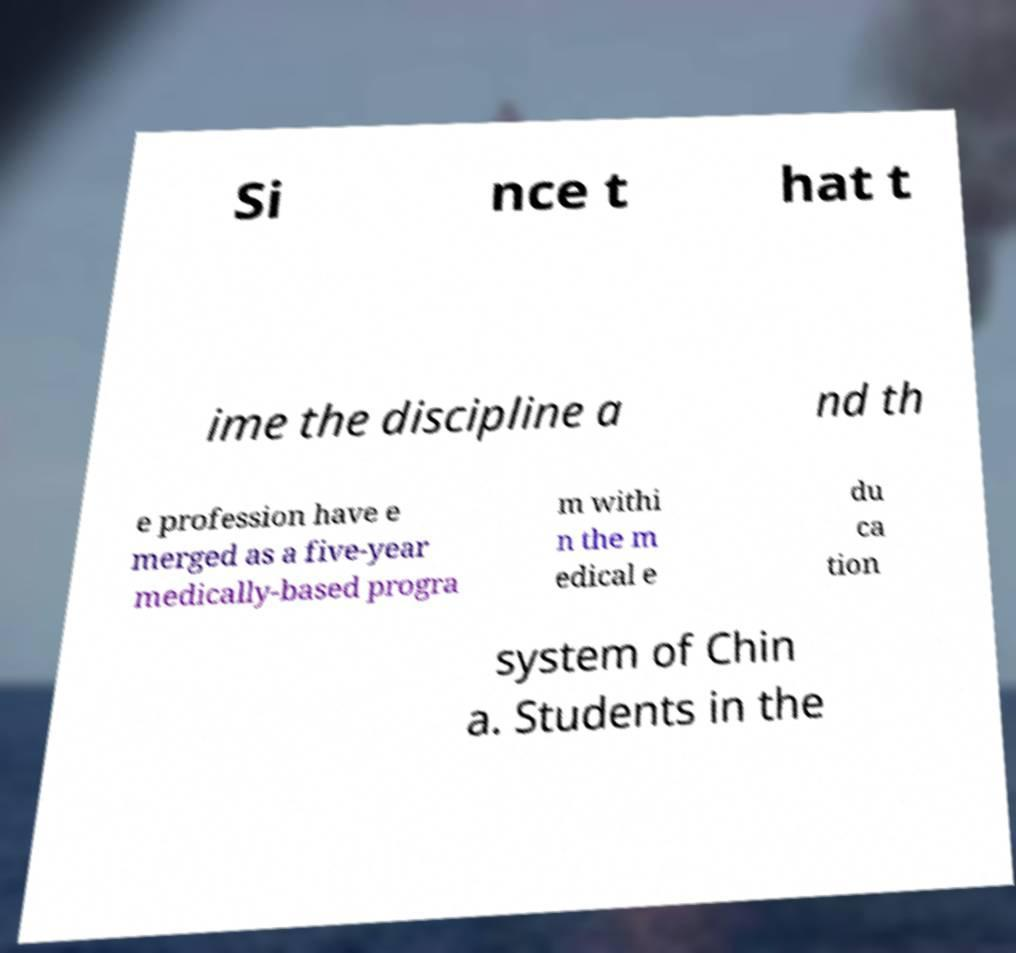Could you extract and type out the text from this image? Si nce t hat t ime the discipline a nd th e profession have e merged as a five-year medically-based progra m withi n the m edical e du ca tion system of Chin a. Students in the 